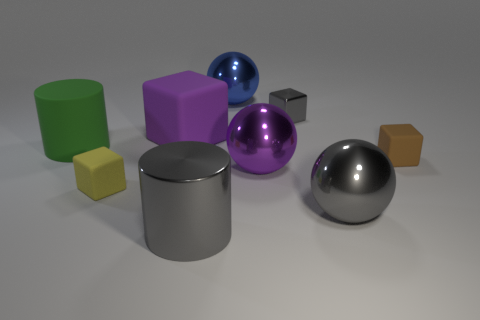Subtract 1 blocks. How many blocks are left? 3 Subtract all cylinders. How many objects are left? 7 Add 6 large gray metallic balls. How many large gray metallic balls are left? 7 Add 6 big cyan shiny cubes. How many big cyan shiny cubes exist? 6 Subtract 1 green cylinders. How many objects are left? 8 Subtract all shiny things. Subtract all green cubes. How many objects are left? 4 